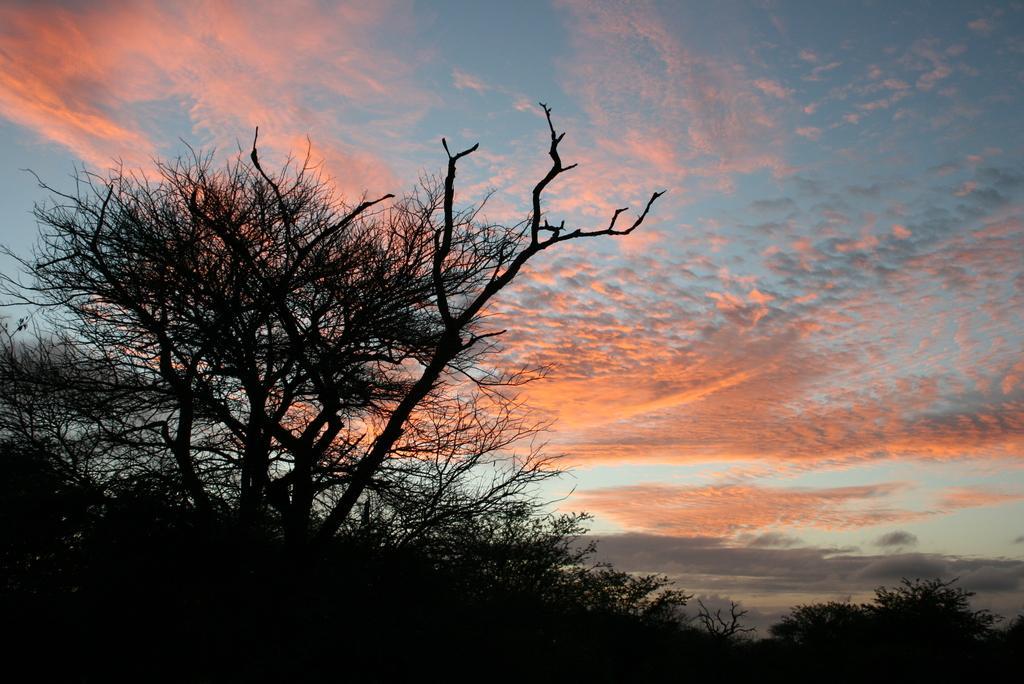In one or two sentences, can you explain what this image depicts? In this image, we can see so many trees. Background there is a cloudy sky. 